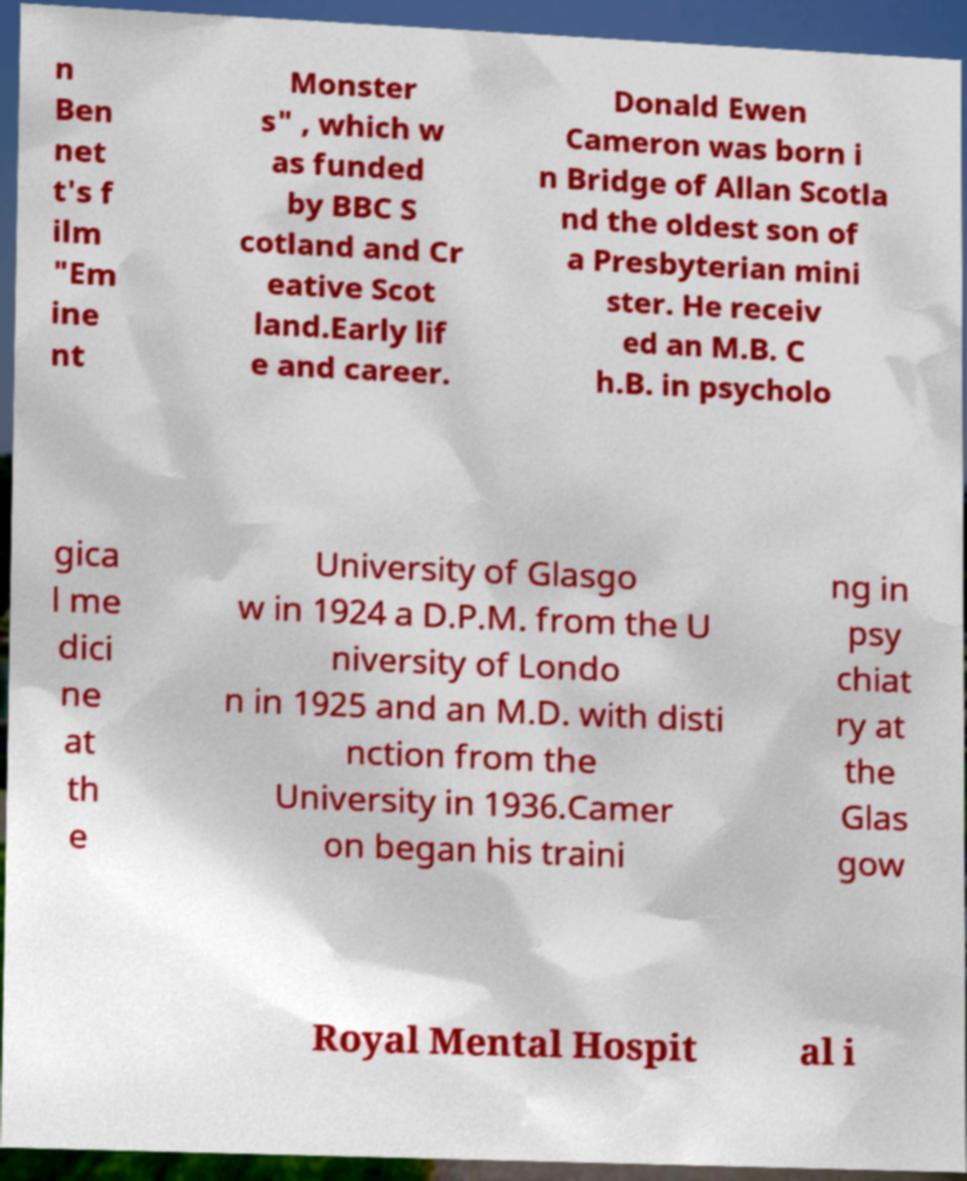Please read and relay the text visible in this image. What does it say? n Ben net t's f ilm "Em ine nt Monster s" , which w as funded by BBC S cotland and Cr eative Scot land.Early lif e and career. Donald Ewen Cameron was born i n Bridge of Allan Scotla nd the oldest son of a Presbyterian mini ster. He receiv ed an M.B. C h.B. in psycholo gica l me dici ne at th e University of Glasgo w in 1924 a D.P.M. from the U niversity of Londo n in 1925 and an M.D. with disti nction from the University in 1936.Camer on began his traini ng in psy chiat ry at the Glas gow Royal Mental Hospit al i 